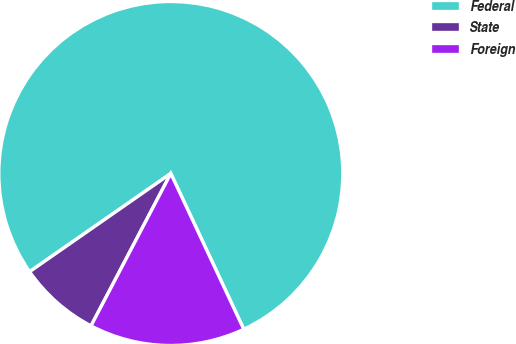Convert chart. <chart><loc_0><loc_0><loc_500><loc_500><pie_chart><fcel>Federal<fcel>State<fcel>Foreign<nl><fcel>77.7%<fcel>7.65%<fcel>14.65%<nl></chart> 